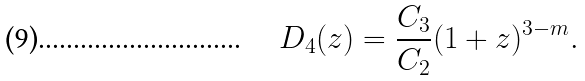<formula> <loc_0><loc_0><loc_500><loc_500>D _ { 4 } ( z ) = \frac { C _ { 3 } } { C _ { 2 } } ( 1 + z ) ^ { 3 - m } .</formula> 